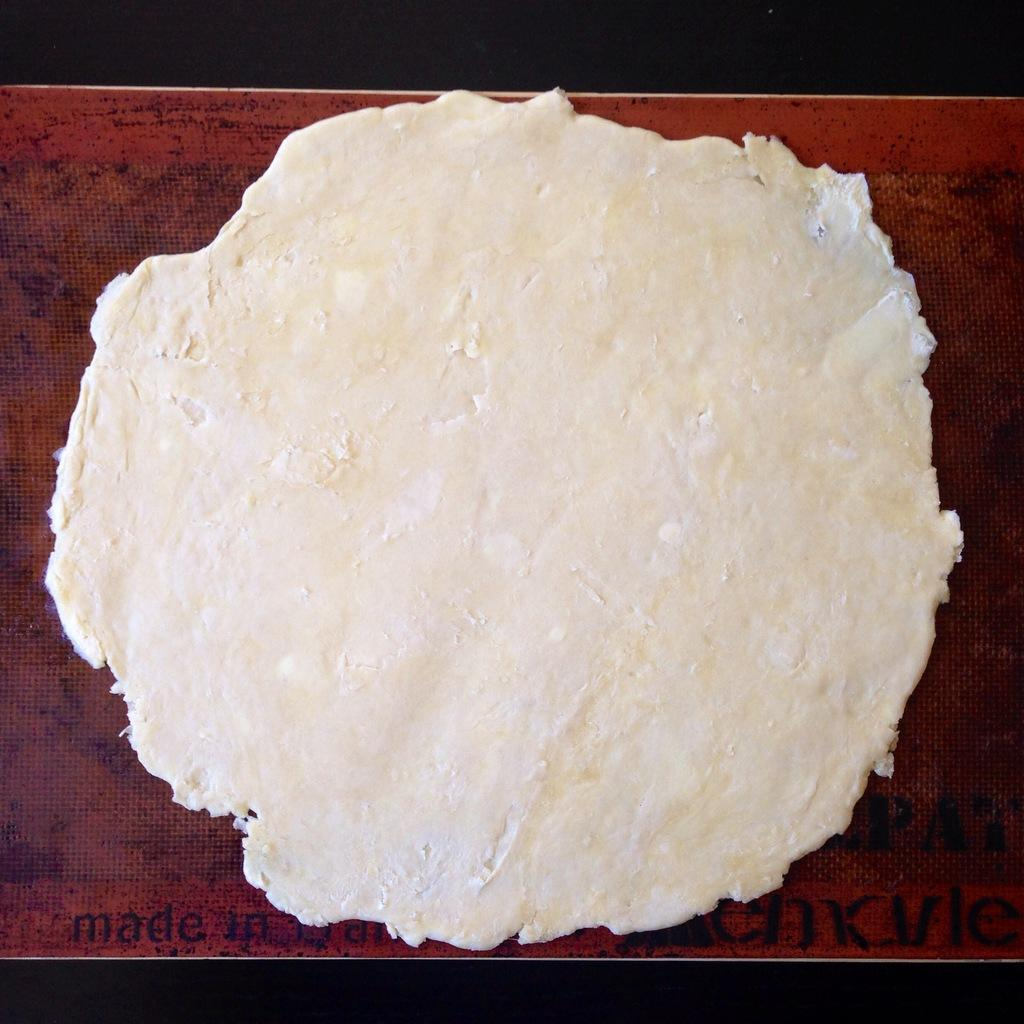What is the main subject of the image? The main subject of the image is dough. How is the dough shaped in the image? The dough is shaped in a round form. What color is the surface on which the dough is placed? The dough is placed on a red surface. What type of notebook is visible on the red surface in the image? There is no notebook present in the image; it only features dough shaped in a round form and placed on a red surface. 